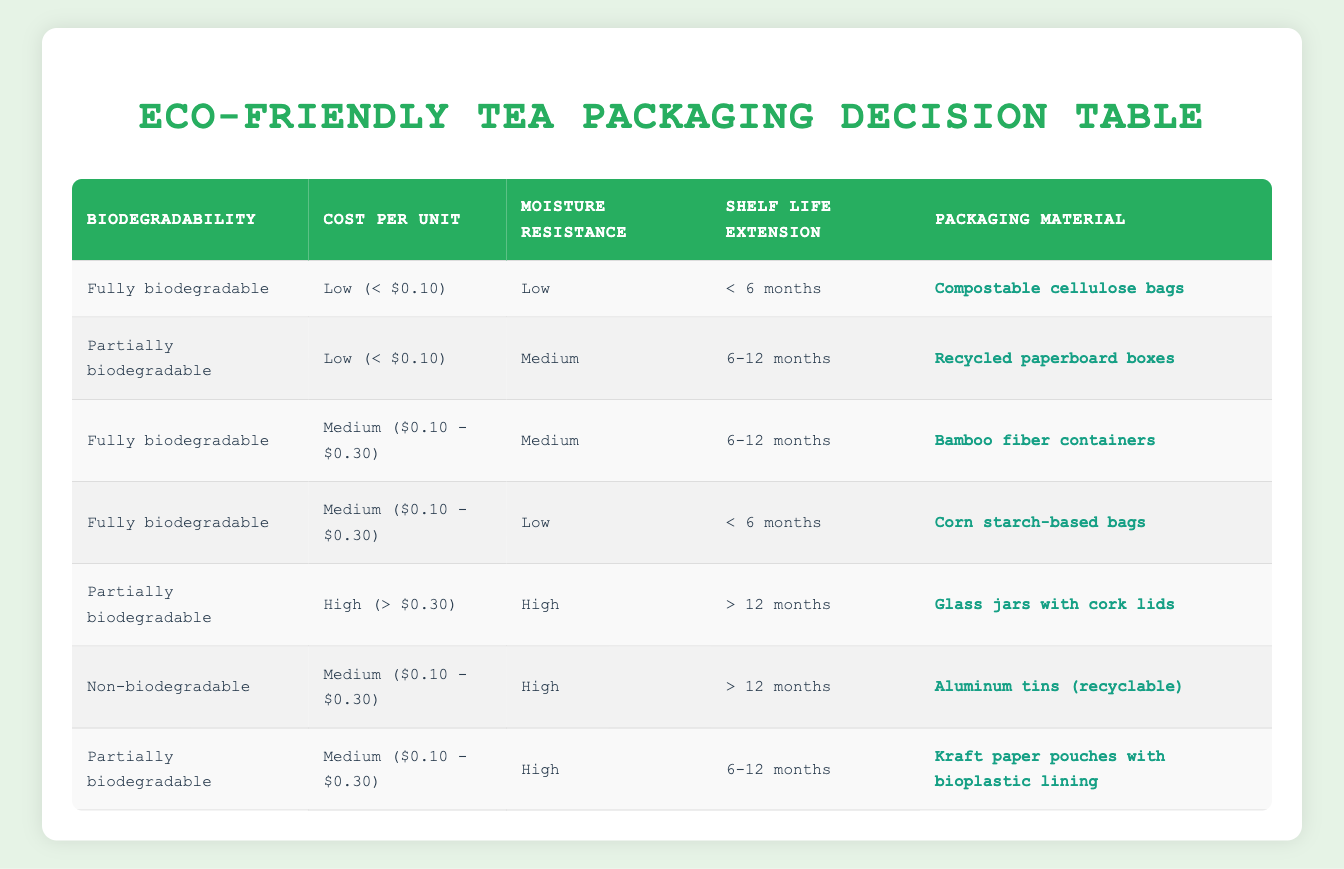What type of packaging material is used for items that are fully biodegradable, have low cost, low moisture resistance, and less than 6 months shelf life? From the table, the row that matches these criteria states: "Fully biodegradable," "Low (< $0.10)," "Low," and "< 6 months." The corresponding packaging material for this condition is "Compostable cellulose bags."
Answer: Compostable cellulose bags What kind of packaging is chosen for partially biodegradable materials that have high moisture resistance and a shelf life of 6-12 months? Looking at the table, we find the row that states "Partially biodegradable," "Medium ($0.10 - $0.30)," "High," and "6-12 months." The packaging material for this condition is "Kraft paper pouches with bioplastic lining."
Answer: Kraft paper pouches with bioplastic lining Is there any packaging material that is fully biodegradable and has a medium cost? By checking the table, there are two rows with the condition "Fully biodegradable" and "Medium ($0.10 - $0.30)." The packaging materials listed are "Bamboo fiber containers" and "Corn starch-based bags." Therefore, the answer is yes.
Answer: Yes How many packaging materials in the table have a high cost (> $0.30)? The table includes one row where the cost is categorized as "High (> $0.30)." The corresponding packaging material is "Glass jars with cork lids." Thus, there is only one.
Answer: 1 Which packaging material allows for the longest shelf life while being partially biodegradable? According to the table, the row for "Partially biodegradable," "High (> $0.30)," "High," and "> 12 months" shows "Glass jars with cork lids." This material allows for over 12 months of shelf life.
Answer: Glass jars with cork lids Are there any packaging materials listed that are non-biodegradable and have a low cost? Scanning the table, there are no rows that indicate a non-biodegradable material with a low cost, so the answer is no.
Answer: No Which packaging provides the shortest shelf life but is still fully biodegradable? The table indicates that for materials with "Fully biodegradable," "Low," and "< 6 months," the packaging is "Compostable cellulose bags," which represent the shortest shelf life for fully biodegradable options.
Answer: Compostable cellulose bags What is the average cost classification among all packaging materials that are fully biodegradable? The table indicates three cost classifications for fully biodegradable materials: "Low (< $0.10)," "Medium ($0.10 - $0.30)." Adding these categorizations gives: (1 low + 2 medium) / 3 results in 1 medium as the averaged classification.
Answer: Medium 